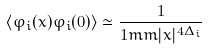<formula> <loc_0><loc_0><loc_500><loc_500>\langle \varphi _ { i } ( x ) \varphi _ { i } ( 0 ) \rangle \simeq \frac { 1 } { 1 m m | x | ^ { 4 \Delta _ { i } } }</formula> 